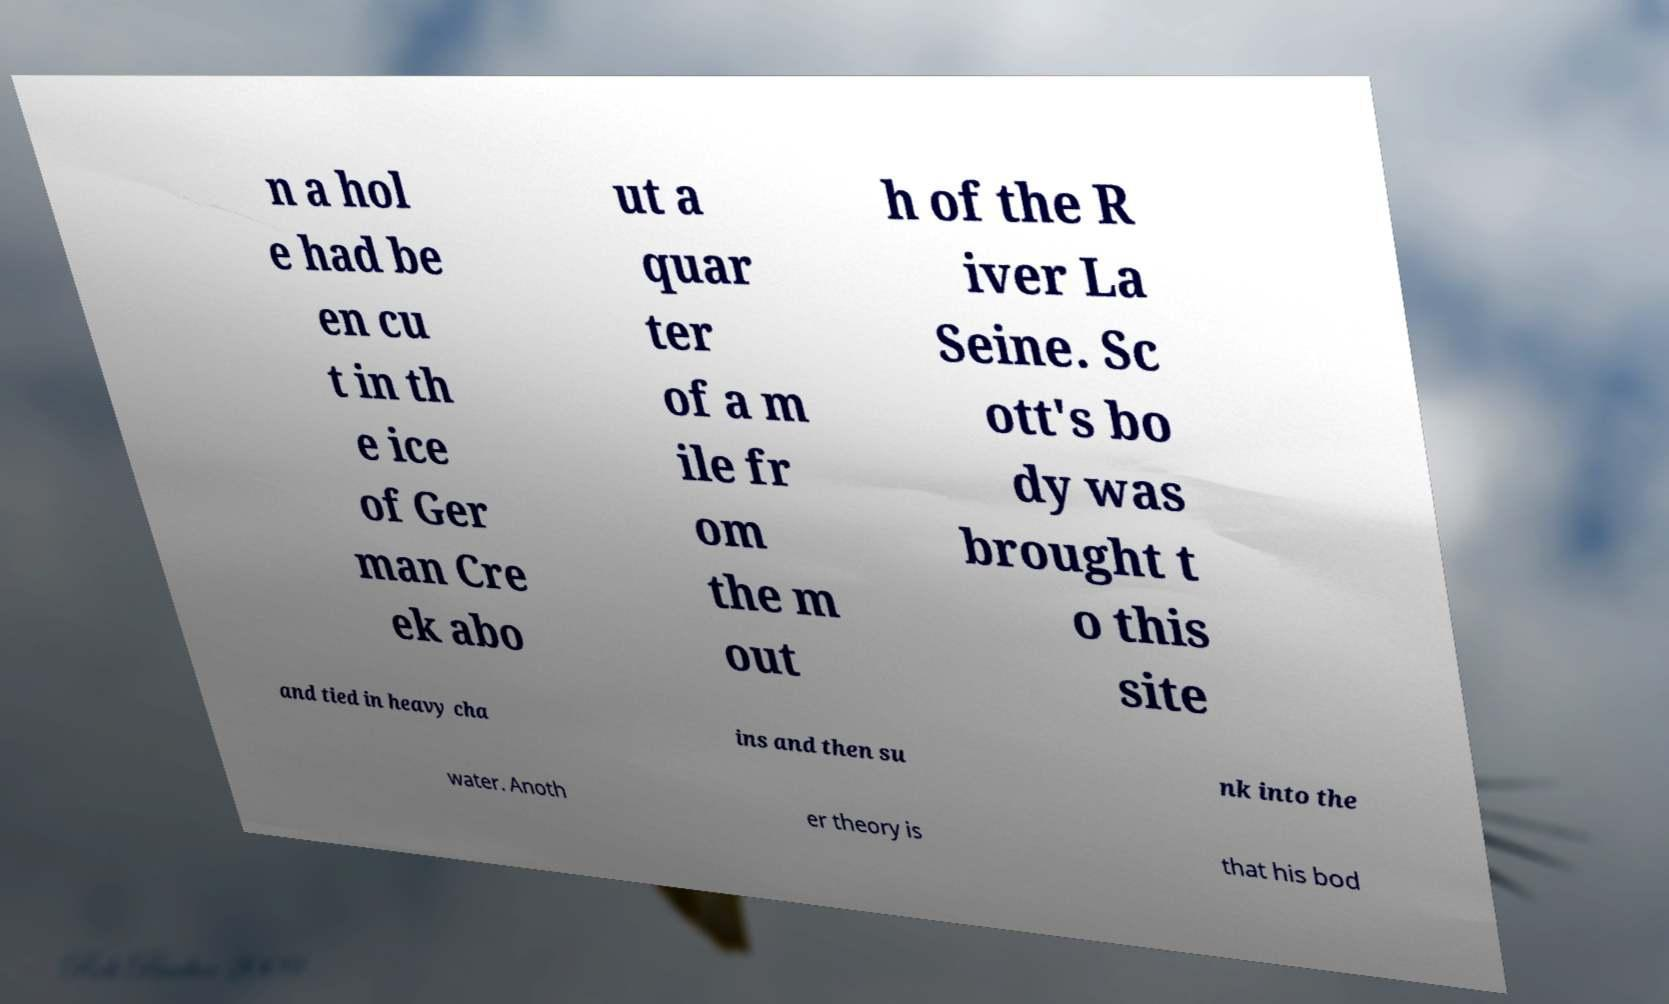For documentation purposes, I need the text within this image transcribed. Could you provide that? n a hol e had be en cu t in th e ice of Ger man Cre ek abo ut a quar ter of a m ile fr om the m out h of the R iver La Seine. Sc ott's bo dy was brought t o this site and tied in heavy cha ins and then su nk into the water. Anoth er theory is that his bod 